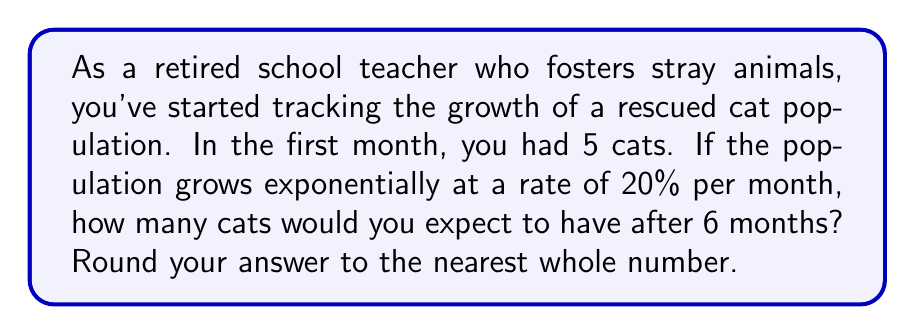Provide a solution to this math problem. Let's approach this step-by-step using the exponential growth formula:

1) The exponential growth formula is:
   $$A = P(1 + r)^t$$
   Where:
   $A$ = Final amount
   $P$ = Initial principal balance
   $r$ = Growth rate (as a decimal)
   $t$ = Time periods elapsed

2) We know:
   $P = 5$ (initial number of cats)
   $r = 0.20$ (20% growth rate)
   $t = 6$ (6 months)

3) Let's plug these values into our formula:
   $$A = 5(1 + 0.20)^6$$

4) Simplify inside the parentheses:
   $$A = 5(1.20)^6$$

5) Calculate the exponent:
   $$A = 5(2.9859)$$

6) Multiply:
   $$A = 14.9295$$

7) Rounding to the nearest whole number:
   $$A ≈ 15$$
Answer: 15 cats 